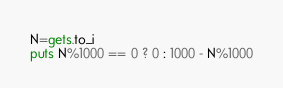Convert code to text. <code><loc_0><loc_0><loc_500><loc_500><_Ruby_>N=gets.to_i
puts N%1000 == 0 ? 0 : 1000 - N%1000</code> 